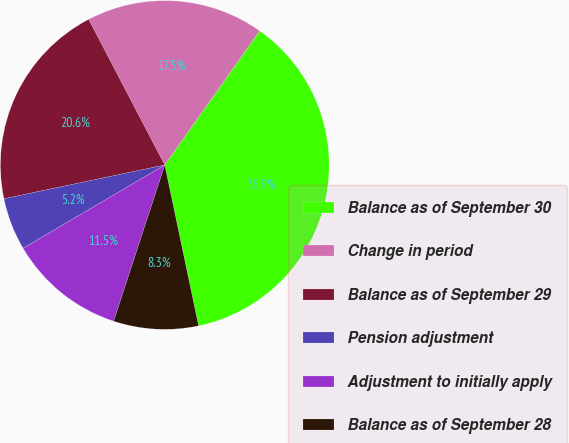<chart> <loc_0><loc_0><loc_500><loc_500><pie_chart><fcel>Balance as of September 30<fcel>Change in period<fcel>Balance as of September 29<fcel>Pension adjustment<fcel>Adjustment to initially apply<fcel>Balance as of September 28<nl><fcel>36.9%<fcel>17.46%<fcel>20.63%<fcel>5.16%<fcel>11.51%<fcel>8.33%<nl></chart> 